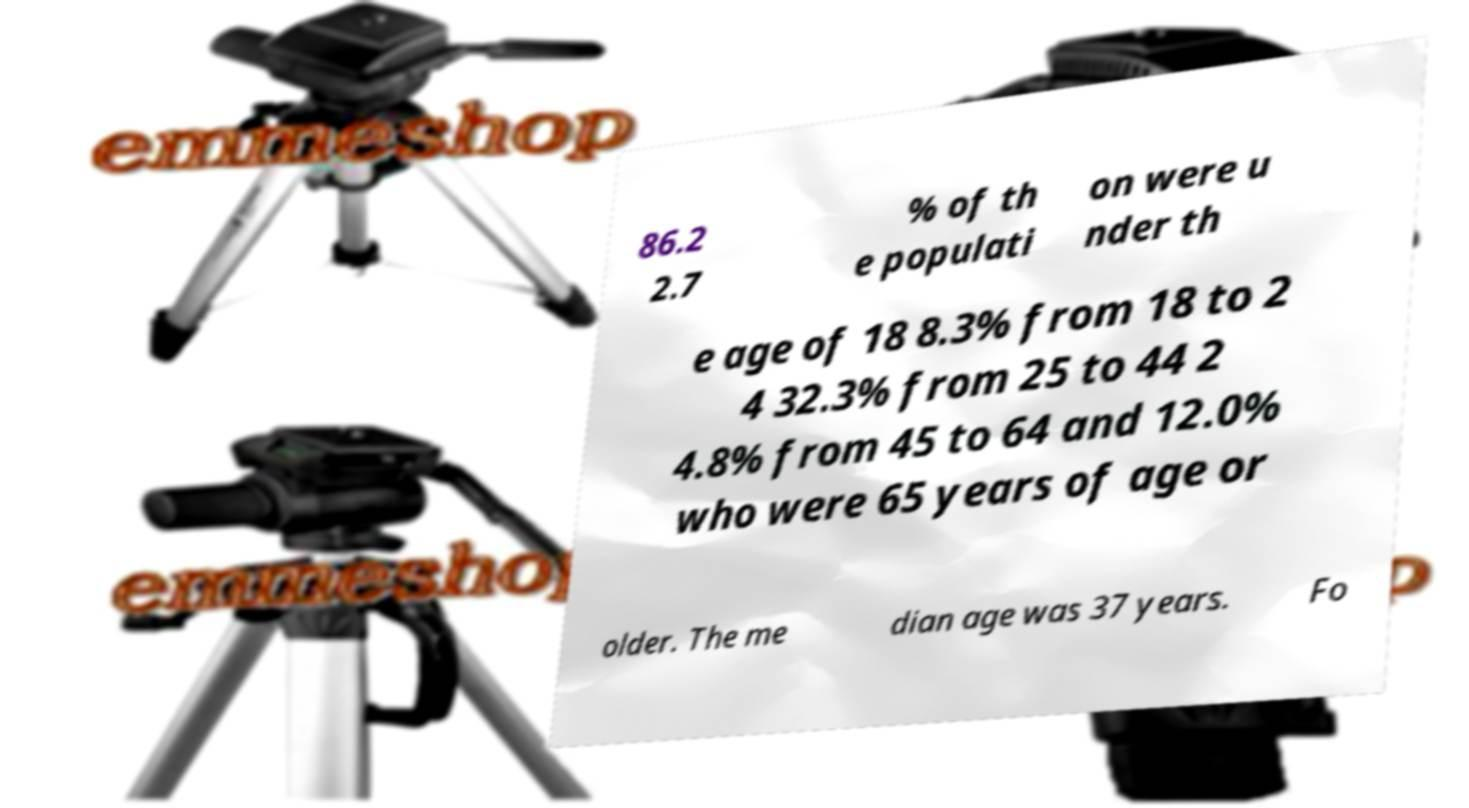Could you assist in decoding the text presented in this image and type it out clearly? 86.2 2.7 % of th e populati on were u nder th e age of 18 8.3% from 18 to 2 4 32.3% from 25 to 44 2 4.8% from 45 to 64 and 12.0% who were 65 years of age or older. The me dian age was 37 years. Fo 